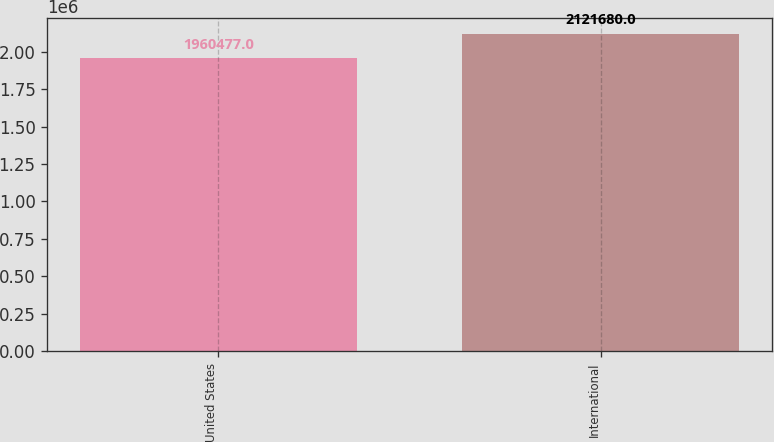Convert chart. <chart><loc_0><loc_0><loc_500><loc_500><bar_chart><fcel>United States<fcel>International<nl><fcel>1.96048e+06<fcel>2.12168e+06<nl></chart> 